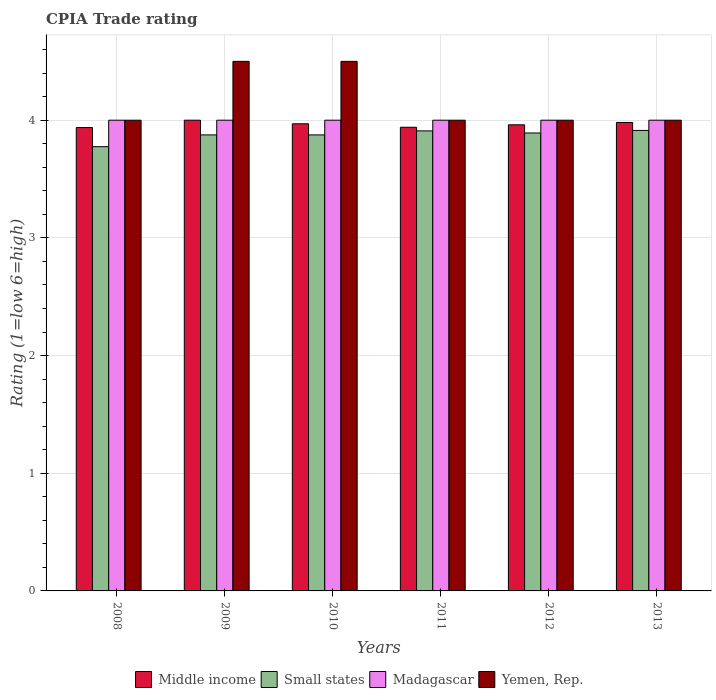How many groups of bars are there?
Provide a succinct answer. 6. How many bars are there on the 1st tick from the left?
Offer a very short reply. 4. How many bars are there on the 2nd tick from the right?
Provide a succinct answer. 4. What is the CPIA rating in Madagascar in 2010?
Your response must be concise. 4. Across all years, what is the maximum CPIA rating in Small states?
Provide a short and direct response. 3.91. Across all years, what is the minimum CPIA rating in Small states?
Make the answer very short. 3.77. What is the total CPIA rating in Middle income in the graph?
Offer a terse response. 23.79. What is the difference between the CPIA rating in Small states in 2009 and that in 2010?
Make the answer very short. 0. What is the difference between the CPIA rating in Yemen, Rep. in 2011 and the CPIA rating in Small states in 2013?
Your answer should be compact. 0.09. What is the average CPIA rating in Small states per year?
Give a very brief answer. 3.87. In the year 2012, what is the difference between the CPIA rating in Middle income and CPIA rating in Small states?
Give a very brief answer. 0.07. What is the ratio of the CPIA rating in Middle income in 2011 to that in 2012?
Your answer should be very brief. 0.99. Is the CPIA rating in Middle income in 2009 less than that in 2011?
Give a very brief answer. No. Is the difference between the CPIA rating in Middle income in 2011 and 2013 greater than the difference between the CPIA rating in Small states in 2011 and 2013?
Provide a succinct answer. No. What is the difference between the highest and the second highest CPIA rating in Yemen, Rep.?
Offer a terse response. 0. What is the difference between the highest and the lowest CPIA rating in Small states?
Ensure brevity in your answer.  0.14. In how many years, is the CPIA rating in Middle income greater than the average CPIA rating in Middle income taken over all years?
Your answer should be very brief. 3. What does the 2nd bar from the left in 2012 represents?
Keep it short and to the point. Small states. What does the 3rd bar from the right in 2010 represents?
Your response must be concise. Small states. Is it the case that in every year, the sum of the CPIA rating in Madagascar and CPIA rating in Yemen, Rep. is greater than the CPIA rating in Middle income?
Provide a short and direct response. Yes. Are all the bars in the graph horizontal?
Your answer should be very brief. No. What is the difference between two consecutive major ticks on the Y-axis?
Provide a short and direct response. 1. Are the values on the major ticks of Y-axis written in scientific E-notation?
Provide a succinct answer. No. Does the graph contain any zero values?
Give a very brief answer. No. Does the graph contain grids?
Make the answer very short. Yes. Where does the legend appear in the graph?
Offer a terse response. Bottom center. How many legend labels are there?
Provide a succinct answer. 4. How are the legend labels stacked?
Your response must be concise. Horizontal. What is the title of the graph?
Provide a short and direct response. CPIA Trade rating. What is the label or title of the X-axis?
Keep it short and to the point. Years. What is the label or title of the Y-axis?
Give a very brief answer. Rating (1=low 6=high). What is the Rating (1=low 6=high) of Middle income in 2008?
Make the answer very short. 3.94. What is the Rating (1=low 6=high) of Small states in 2008?
Offer a terse response. 3.77. What is the Rating (1=low 6=high) in Madagascar in 2008?
Give a very brief answer. 4. What is the Rating (1=low 6=high) of Yemen, Rep. in 2008?
Offer a terse response. 4. What is the Rating (1=low 6=high) of Small states in 2009?
Your answer should be compact. 3.88. What is the Rating (1=low 6=high) in Middle income in 2010?
Offer a terse response. 3.97. What is the Rating (1=low 6=high) of Small states in 2010?
Provide a succinct answer. 3.88. What is the Rating (1=low 6=high) of Madagascar in 2010?
Offer a terse response. 4. What is the Rating (1=low 6=high) of Yemen, Rep. in 2010?
Keep it short and to the point. 4.5. What is the Rating (1=low 6=high) in Middle income in 2011?
Your answer should be very brief. 3.94. What is the Rating (1=low 6=high) in Small states in 2011?
Ensure brevity in your answer.  3.91. What is the Rating (1=low 6=high) of Middle income in 2012?
Make the answer very short. 3.96. What is the Rating (1=low 6=high) of Small states in 2012?
Provide a short and direct response. 3.89. What is the Rating (1=low 6=high) of Yemen, Rep. in 2012?
Your answer should be compact. 4. What is the Rating (1=low 6=high) in Middle income in 2013?
Make the answer very short. 3.98. What is the Rating (1=low 6=high) of Small states in 2013?
Offer a very short reply. 3.91. What is the Rating (1=low 6=high) of Yemen, Rep. in 2013?
Offer a very short reply. 4. Across all years, what is the maximum Rating (1=low 6=high) of Middle income?
Offer a terse response. 4. Across all years, what is the maximum Rating (1=low 6=high) in Small states?
Provide a succinct answer. 3.91. Across all years, what is the minimum Rating (1=low 6=high) of Middle income?
Provide a short and direct response. 3.94. Across all years, what is the minimum Rating (1=low 6=high) of Small states?
Give a very brief answer. 3.77. What is the total Rating (1=low 6=high) in Middle income in the graph?
Your answer should be very brief. 23.79. What is the total Rating (1=low 6=high) of Small states in the graph?
Make the answer very short. 23.24. What is the total Rating (1=low 6=high) in Yemen, Rep. in the graph?
Give a very brief answer. 25. What is the difference between the Rating (1=low 6=high) in Middle income in 2008 and that in 2009?
Provide a succinct answer. -0.06. What is the difference between the Rating (1=low 6=high) of Madagascar in 2008 and that in 2009?
Provide a short and direct response. 0. What is the difference between the Rating (1=low 6=high) of Middle income in 2008 and that in 2010?
Your answer should be compact. -0.03. What is the difference between the Rating (1=low 6=high) of Small states in 2008 and that in 2010?
Your answer should be very brief. -0.1. What is the difference between the Rating (1=low 6=high) in Yemen, Rep. in 2008 and that in 2010?
Ensure brevity in your answer.  -0.5. What is the difference between the Rating (1=low 6=high) in Middle income in 2008 and that in 2011?
Offer a very short reply. -0. What is the difference between the Rating (1=low 6=high) of Small states in 2008 and that in 2011?
Your answer should be compact. -0.13. What is the difference between the Rating (1=low 6=high) in Yemen, Rep. in 2008 and that in 2011?
Ensure brevity in your answer.  0. What is the difference between the Rating (1=low 6=high) of Middle income in 2008 and that in 2012?
Provide a succinct answer. -0.02. What is the difference between the Rating (1=low 6=high) of Small states in 2008 and that in 2012?
Make the answer very short. -0.12. What is the difference between the Rating (1=low 6=high) of Madagascar in 2008 and that in 2012?
Your answer should be very brief. 0. What is the difference between the Rating (1=low 6=high) of Yemen, Rep. in 2008 and that in 2012?
Ensure brevity in your answer.  0. What is the difference between the Rating (1=low 6=high) in Middle income in 2008 and that in 2013?
Ensure brevity in your answer.  -0.04. What is the difference between the Rating (1=low 6=high) in Small states in 2008 and that in 2013?
Offer a terse response. -0.14. What is the difference between the Rating (1=low 6=high) of Middle income in 2009 and that in 2010?
Give a very brief answer. 0.03. What is the difference between the Rating (1=low 6=high) in Yemen, Rep. in 2009 and that in 2010?
Give a very brief answer. 0. What is the difference between the Rating (1=low 6=high) in Middle income in 2009 and that in 2011?
Your answer should be very brief. 0.06. What is the difference between the Rating (1=low 6=high) in Small states in 2009 and that in 2011?
Give a very brief answer. -0.03. What is the difference between the Rating (1=low 6=high) in Yemen, Rep. in 2009 and that in 2011?
Make the answer very short. 0.5. What is the difference between the Rating (1=low 6=high) of Middle income in 2009 and that in 2012?
Offer a very short reply. 0.04. What is the difference between the Rating (1=low 6=high) in Small states in 2009 and that in 2012?
Your response must be concise. -0.02. What is the difference between the Rating (1=low 6=high) of Madagascar in 2009 and that in 2012?
Keep it short and to the point. 0. What is the difference between the Rating (1=low 6=high) of Middle income in 2009 and that in 2013?
Keep it short and to the point. 0.02. What is the difference between the Rating (1=low 6=high) in Small states in 2009 and that in 2013?
Provide a succinct answer. -0.04. What is the difference between the Rating (1=low 6=high) in Madagascar in 2009 and that in 2013?
Your response must be concise. 0. What is the difference between the Rating (1=low 6=high) in Middle income in 2010 and that in 2011?
Your answer should be compact. 0.03. What is the difference between the Rating (1=low 6=high) in Small states in 2010 and that in 2011?
Provide a short and direct response. -0.03. What is the difference between the Rating (1=low 6=high) in Madagascar in 2010 and that in 2011?
Keep it short and to the point. 0. What is the difference between the Rating (1=low 6=high) of Middle income in 2010 and that in 2012?
Your response must be concise. 0.01. What is the difference between the Rating (1=low 6=high) of Small states in 2010 and that in 2012?
Ensure brevity in your answer.  -0.02. What is the difference between the Rating (1=low 6=high) of Middle income in 2010 and that in 2013?
Offer a very short reply. -0.01. What is the difference between the Rating (1=low 6=high) in Small states in 2010 and that in 2013?
Your answer should be very brief. -0.04. What is the difference between the Rating (1=low 6=high) of Yemen, Rep. in 2010 and that in 2013?
Make the answer very short. 0.5. What is the difference between the Rating (1=low 6=high) of Middle income in 2011 and that in 2012?
Offer a terse response. -0.02. What is the difference between the Rating (1=low 6=high) in Small states in 2011 and that in 2012?
Give a very brief answer. 0.02. What is the difference between the Rating (1=low 6=high) in Madagascar in 2011 and that in 2012?
Ensure brevity in your answer.  0. What is the difference between the Rating (1=low 6=high) of Yemen, Rep. in 2011 and that in 2012?
Make the answer very short. 0. What is the difference between the Rating (1=low 6=high) in Middle income in 2011 and that in 2013?
Offer a terse response. -0.04. What is the difference between the Rating (1=low 6=high) in Small states in 2011 and that in 2013?
Offer a terse response. -0. What is the difference between the Rating (1=low 6=high) in Yemen, Rep. in 2011 and that in 2013?
Provide a short and direct response. 0. What is the difference between the Rating (1=low 6=high) in Middle income in 2012 and that in 2013?
Keep it short and to the point. -0.02. What is the difference between the Rating (1=low 6=high) in Small states in 2012 and that in 2013?
Provide a succinct answer. -0.02. What is the difference between the Rating (1=low 6=high) of Middle income in 2008 and the Rating (1=low 6=high) of Small states in 2009?
Make the answer very short. 0.06. What is the difference between the Rating (1=low 6=high) in Middle income in 2008 and the Rating (1=low 6=high) in Madagascar in 2009?
Give a very brief answer. -0.06. What is the difference between the Rating (1=low 6=high) in Middle income in 2008 and the Rating (1=low 6=high) in Yemen, Rep. in 2009?
Keep it short and to the point. -0.56. What is the difference between the Rating (1=low 6=high) of Small states in 2008 and the Rating (1=low 6=high) of Madagascar in 2009?
Provide a short and direct response. -0.23. What is the difference between the Rating (1=low 6=high) of Small states in 2008 and the Rating (1=low 6=high) of Yemen, Rep. in 2009?
Make the answer very short. -0.72. What is the difference between the Rating (1=low 6=high) in Middle income in 2008 and the Rating (1=low 6=high) in Small states in 2010?
Your answer should be very brief. 0.06. What is the difference between the Rating (1=low 6=high) of Middle income in 2008 and the Rating (1=low 6=high) of Madagascar in 2010?
Provide a short and direct response. -0.06. What is the difference between the Rating (1=low 6=high) of Middle income in 2008 and the Rating (1=low 6=high) of Yemen, Rep. in 2010?
Provide a short and direct response. -0.56. What is the difference between the Rating (1=low 6=high) of Small states in 2008 and the Rating (1=low 6=high) of Madagascar in 2010?
Offer a very short reply. -0.23. What is the difference between the Rating (1=low 6=high) of Small states in 2008 and the Rating (1=low 6=high) of Yemen, Rep. in 2010?
Your answer should be very brief. -0.72. What is the difference between the Rating (1=low 6=high) in Madagascar in 2008 and the Rating (1=low 6=high) in Yemen, Rep. in 2010?
Offer a terse response. -0.5. What is the difference between the Rating (1=low 6=high) in Middle income in 2008 and the Rating (1=low 6=high) in Small states in 2011?
Keep it short and to the point. 0.03. What is the difference between the Rating (1=low 6=high) of Middle income in 2008 and the Rating (1=low 6=high) of Madagascar in 2011?
Provide a short and direct response. -0.06. What is the difference between the Rating (1=low 6=high) in Middle income in 2008 and the Rating (1=low 6=high) in Yemen, Rep. in 2011?
Keep it short and to the point. -0.06. What is the difference between the Rating (1=low 6=high) in Small states in 2008 and the Rating (1=low 6=high) in Madagascar in 2011?
Ensure brevity in your answer.  -0.23. What is the difference between the Rating (1=low 6=high) in Small states in 2008 and the Rating (1=low 6=high) in Yemen, Rep. in 2011?
Your answer should be compact. -0.23. What is the difference between the Rating (1=low 6=high) in Middle income in 2008 and the Rating (1=low 6=high) in Small states in 2012?
Your response must be concise. 0.05. What is the difference between the Rating (1=low 6=high) in Middle income in 2008 and the Rating (1=low 6=high) in Madagascar in 2012?
Make the answer very short. -0.06. What is the difference between the Rating (1=low 6=high) in Middle income in 2008 and the Rating (1=low 6=high) in Yemen, Rep. in 2012?
Your response must be concise. -0.06. What is the difference between the Rating (1=low 6=high) in Small states in 2008 and the Rating (1=low 6=high) in Madagascar in 2012?
Provide a succinct answer. -0.23. What is the difference between the Rating (1=low 6=high) in Small states in 2008 and the Rating (1=low 6=high) in Yemen, Rep. in 2012?
Your response must be concise. -0.23. What is the difference between the Rating (1=low 6=high) of Middle income in 2008 and the Rating (1=low 6=high) of Small states in 2013?
Make the answer very short. 0.02. What is the difference between the Rating (1=low 6=high) in Middle income in 2008 and the Rating (1=low 6=high) in Madagascar in 2013?
Offer a terse response. -0.06. What is the difference between the Rating (1=low 6=high) of Middle income in 2008 and the Rating (1=low 6=high) of Yemen, Rep. in 2013?
Ensure brevity in your answer.  -0.06. What is the difference between the Rating (1=low 6=high) of Small states in 2008 and the Rating (1=low 6=high) of Madagascar in 2013?
Ensure brevity in your answer.  -0.23. What is the difference between the Rating (1=low 6=high) of Small states in 2008 and the Rating (1=low 6=high) of Yemen, Rep. in 2013?
Your answer should be compact. -0.23. What is the difference between the Rating (1=low 6=high) of Small states in 2009 and the Rating (1=low 6=high) of Madagascar in 2010?
Provide a succinct answer. -0.12. What is the difference between the Rating (1=low 6=high) in Small states in 2009 and the Rating (1=low 6=high) in Yemen, Rep. in 2010?
Offer a terse response. -0.62. What is the difference between the Rating (1=low 6=high) of Madagascar in 2009 and the Rating (1=low 6=high) of Yemen, Rep. in 2010?
Provide a short and direct response. -0.5. What is the difference between the Rating (1=low 6=high) in Middle income in 2009 and the Rating (1=low 6=high) in Small states in 2011?
Your answer should be very brief. 0.09. What is the difference between the Rating (1=low 6=high) in Middle income in 2009 and the Rating (1=low 6=high) in Yemen, Rep. in 2011?
Your answer should be compact. 0. What is the difference between the Rating (1=low 6=high) in Small states in 2009 and the Rating (1=low 6=high) in Madagascar in 2011?
Your response must be concise. -0.12. What is the difference between the Rating (1=low 6=high) of Small states in 2009 and the Rating (1=low 6=high) of Yemen, Rep. in 2011?
Your response must be concise. -0.12. What is the difference between the Rating (1=low 6=high) in Middle income in 2009 and the Rating (1=low 6=high) in Small states in 2012?
Provide a succinct answer. 0.11. What is the difference between the Rating (1=low 6=high) of Small states in 2009 and the Rating (1=low 6=high) of Madagascar in 2012?
Your answer should be very brief. -0.12. What is the difference between the Rating (1=low 6=high) in Small states in 2009 and the Rating (1=low 6=high) in Yemen, Rep. in 2012?
Offer a very short reply. -0.12. What is the difference between the Rating (1=low 6=high) in Middle income in 2009 and the Rating (1=low 6=high) in Small states in 2013?
Ensure brevity in your answer.  0.09. What is the difference between the Rating (1=low 6=high) of Middle income in 2009 and the Rating (1=low 6=high) of Madagascar in 2013?
Your answer should be compact. 0. What is the difference between the Rating (1=low 6=high) of Middle income in 2009 and the Rating (1=low 6=high) of Yemen, Rep. in 2013?
Your answer should be very brief. 0. What is the difference between the Rating (1=low 6=high) of Small states in 2009 and the Rating (1=low 6=high) of Madagascar in 2013?
Provide a short and direct response. -0.12. What is the difference between the Rating (1=low 6=high) in Small states in 2009 and the Rating (1=low 6=high) in Yemen, Rep. in 2013?
Provide a short and direct response. -0.12. What is the difference between the Rating (1=low 6=high) in Middle income in 2010 and the Rating (1=low 6=high) in Small states in 2011?
Make the answer very short. 0.06. What is the difference between the Rating (1=low 6=high) in Middle income in 2010 and the Rating (1=low 6=high) in Madagascar in 2011?
Your answer should be compact. -0.03. What is the difference between the Rating (1=low 6=high) of Middle income in 2010 and the Rating (1=low 6=high) of Yemen, Rep. in 2011?
Keep it short and to the point. -0.03. What is the difference between the Rating (1=low 6=high) of Small states in 2010 and the Rating (1=low 6=high) of Madagascar in 2011?
Offer a very short reply. -0.12. What is the difference between the Rating (1=low 6=high) of Small states in 2010 and the Rating (1=low 6=high) of Yemen, Rep. in 2011?
Provide a short and direct response. -0.12. What is the difference between the Rating (1=low 6=high) of Madagascar in 2010 and the Rating (1=low 6=high) of Yemen, Rep. in 2011?
Your answer should be very brief. 0. What is the difference between the Rating (1=low 6=high) in Middle income in 2010 and the Rating (1=low 6=high) in Small states in 2012?
Your answer should be very brief. 0.08. What is the difference between the Rating (1=low 6=high) in Middle income in 2010 and the Rating (1=low 6=high) in Madagascar in 2012?
Provide a succinct answer. -0.03. What is the difference between the Rating (1=low 6=high) of Middle income in 2010 and the Rating (1=low 6=high) of Yemen, Rep. in 2012?
Your response must be concise. -0.03. What is the difference between the Rating (1=low 6=high) in Small states in 2010 and the Rating (1=low 6=high) in Madagascar in 2012?
Keep it short and to the point. -0.12. What is the difference between the Rating (1=low 6=high) of Small states in 2010 and the Rating (1=low 6=high) of Yemen, Rep. in 2012?
Your answer should be very brief. -0.12. What is the difference between the Rating (1=low 6=high) of Madagascar in 2010 and the Rating (1=low 6=high) of Yemen, Rep. in 2012?
Provide a succinct answer. 0. What is the difference between the Rating (1=low 6=high) in Middle income in 2010 and the Rating (1=low 6=high) in Small states in 2013?
Your answer should be compact. 0.06. What is the difference between the Rating (1=low 6=high) of Middle income in 2010 and the Rating (1=low 6=high) of Madagascar in 2013?
Provide a short and direct response. -0.03. What is the difference between the Rating (1=low 6=high) of Middle income in 2010 and the Rating (1=low 6=high) of Yemen, Rep. in 2013?
Give a very brief answer. -0.03. What is the difference between the Rating (1=low 6=high) in Small states in 2010 and the Rating (1=low 6=high) in Madagascar in 2013?
Your answer should be very brief. -0.12. What is the difference between the Rating (1=low 6=high) of Small states in 2010 and the Rating (1=low 6=high) of Yemen, Rep. in 2013?
Offer a terse response. -0.12. What is the difference between the Rating (1=low 6=high) in Middle income in 2011 and the Rating (1=low 6=high) in Small states in 2012?
Offer a very short reply. 0.05. What is the difference between the Rating (1=low 6=high) of Middle income in 2011 and the Rating (1=low 6=high) of Madagascar in 2012?
Give a very brief answer. -0.06. What is the difference between the Rating (1=low 6=high) of Middle income in 2011 and the Rating (1=low 6=high) of Yemen, Rep. in 2012?
Offer a terse response. -0.06. What is the difference between the Rating (1=low 6=high) in Small states in 2011 and the Rating (1=low 6=high) in Madagascar in 2012?
Your answer should be compact. -0.09. What is the difference between the Rating (1=low 6=high) in Small states in 2011 and the Rating (1=low 6=high) in Yemen, Rep. in 2012?
Provide a short and direct response. -0.09. What is the difference between the Rating (1=low 6=high) in Madagascar in 2011 and the Rating (1=low 6=high) in Yemen, Rep. in 2012?
Your answer should be compact. 0. What is the difference between the Rating (1=low 6=high) of Middle income in 2011 and the Rating (1=low 6=high) of Small states in 2013?
Offer a very short reply. 0.03. What is the difference between the Rating (1=low 6=high) in Middle income in 2011 and the Rating (1=low 6=high) in Madagascar in 2013?
Your response must be concise. -0.06. What is the difference between the Rating (1=low 6=high) of Middle income in 2011 and the Rating (1=low 6=high) of Yemen, Rep. in 2013?
Provide a succinct answer. -0.06. What is the difference between the Rating (1=low 6=high) in Small states in 2011 and the Rating (1=low 6=high) in Madagascar in 2013?
Your answer should be very brief. -0.09. What is the difference between the Rating (1=low 6=high) of Small states in 2011 and the Rating (1=low 6=high) of Yemen, Rep. in 2013?
Offer a terse response. -0.09. What is the difference between the Rating (1=low 6=high) in Middle income in 2012 and the Rating (1=low 6=high) in Small states in 2013?
Your answer should be very brief. 0.05. What is the difference between the Rating (1=low 6=high) of Middle income in 2012 and the Rating (1=low 6=high) of Madagascar in 2013?
Provide a short and direct response. -0.04. What is the difference between the Rating (1=low 6=high) in Middle income in 2012 and the Rating (1=low 6=high) in Yemen, Rep. in 2013?
Provide a short and direct response. -0.04. What is the difference between the Rating (1=low 6=high) of Small states in 2012 and the Rating (1=low 6=high) of Madagascar in 2013?
Offer a terse response. -0.11. What is the difference between the Rating (1=low 6=high) of Small states in 2012 and the Rating (1=low 6=high) of Yemen, Rep. in 2013?
Offer a very short reply. -0.11. What is the difference between the Rating (1=low 6=high) in Madagascar in 2012 and the Rating (1=low 6=high) in Yemen, Rep. in 2013?
Provide a short and direct response. 0. What is the average Rating (1=low 6=high) of Middle income per year?
Provide a short and direct response. 3.96. What is the average Rating (1=low 6=high) in Small states per year?
Make the answer very short. 3.87. What is the average Rating (1=low 6=high) of Madagascar per year?
Keep it short and to the point. 4. What is the average Rating (1=low 6=high) of Yemen, Rep. per year?
Provide a succinct answer. 4.17. In the year 2008, what is the difference between the Rating (1=low 6=high) of Middle income and Rating (1=low 6=high) of Small states?
Give a very brief answer. 0.16. In the year 2008, what is the difference between the Rating (1=low 6=high) in Middle income and Rating (1=low 6=high) in Madagascar?
Your answer should be compact. -0.06. In the year 2008, what is the difference between the Rating (1=low 6=high) of Middle income and Rating (1=low 6=high) of Yemen, Rep.?
Your response must be concise. -0.06. In the year 2008, what is the difference between the Rating (1=low 6=high) of Small states and Rating (1=low 6=high) of Madagascar?
Your answer should be compact. -0.23. In the year 2008, what is the difference between the Rating (1=low 6=high) of Small states and Rating (1=low 6=high) of Yemen, Rep.?
Offer a terse response. -0.23. In the year 2008, what is the difference between the Rating (1=low 6=high) in Madagascar and Rating (1=low 6=high) in Yemen, Rep.?
Offer a terse response. 0. In the year 2009, what is the difference between the Rating (1=low 6=high) in Middle income and Rating (1=low 6=high) in Madagascar?
Your answer should be very brief. 0. In the year 2009, what is the difference between the Rating (1=low 6=high) in Small states and Rating (1=low 6=high) in Madagascar?
Give a very brief answer. -0.12. In the year 2009, what is the difference between the Rating (1=low 6=high) of Small states and Rating (1=low 6=high) of Yemen, Rep.?
Your answer should be very brief. -0.62. In the year 2009, what is the difference between the Rating (1=low 6=high) in Madagascar and Rating (1=low 6=high) in Yemen, Rep.?
Your response must be concise. -0.5. In the year 2010, what is the difference between the Rating (1=low 6=high) in Middle income and Rating (1=low 6=high) in Small states?
Give a very brief answer. 0.09. In the year 2010, what is the difference between the Rating (1=low 6=high) in Middle income and Rating (1=low 6=high) in Madagascar?
Offer a terse response. -0.03. In the year 2010, what is the difference between the Rating (1=low 6=high) of Middle income and Rating (1=low 6=high) of Yemen, Rep.?
Provide a succinct answer. -0.53. In the year 2010, what is the difference between the Rating (1=low 6=high) in Small states and Rating (1=low 6=high) in Madagascar?
Offer a terse response. -0.12. In the year 2010, what is the difference between the Rating (1=low 6=high) of Small states and Rating (1=low 6=high) of Yemen, Rep.?
Make the answer very short. -0.62. In the year 2010, what is the difference between the Rating (1=low 6=high) of Madagascar and Rating (1=low 6=high) of Yemen, Rep.?
Your response must be concise. -0.5. In the year 2011, what is the difference between the Rating (1=low 6=high) in Middle income and Rating (1=low 6=high) in Small states?
Provide a succinct answer. 0.03. In the year 2011, what is the difference between the Rating (1=low 6=high) of Middle income and Rating (1=low 6=high) of Madagascar?
Your response must be concise. -0.06. In the year 2011, what is the difference between the Rating (1=low 6=high) of Middle income and Rating (1=low 6=high) of Yemen, Rep.?
Give a very brief answer. -0.06. In the year 2011, what is the difference between the Rating (1=low 6=high) in Small states and Rating (1=low 6=high) in Madagascar?
Keep it short and to the point. -0.09. In the year 2011, what is the difference between the Rating (1=low 6=high) of Small states and Rating (1=low 6=high) of Yemen, Rep.?
Make the answer very short. -0.09. In the year 2011, what is the difference between the Rating (1=low 6=high) of Madagascar and Rating (1=low 6=high) of Yemen, Rep.?
Ensure brevity in your answer.  0. In the year 2012, what is the difference between the Rating (1=low 6=high) in Middle income and Rating (1=low 6=high) in Small states?
Give a very brief answer. 0.07. In the year 2012, what is the difference between the Rating (1=low 6=high) in Middle income and Rating (1=low 6=high) in Madagascar?
Offer a terse response. -0.04. In the year 2012, what is the difference between the Rating (1=low 6=high) of Middle income and Rating (1=low 6=high) of Yemen, Rep.?
Your answer should be compact. -0.04. In the year 2012, what is the difference between the Rating (1=low 6=high) of Small states and Rating (1=low 6=high) of Madagascar?
Your answer should be very brief. -0.11. In the year 2012, what is the difference between the Rating (1=low 6=high) in Small states and Rating (1=low 6=high) in Yemen, Rep.?
Provide a short and direct response. -0.11. In the year 2012, what is the difference between the Rating (1=low 6=high) of Madagascar and Rating (1=low 6=high) of Yemen, Rep.?
Your answer should be very brief. 0. In the year 2013, what is the difference between the Rating (1=low 6=high) of Middle income and Rating (1=low 6=high) of Small states?
Provide a short and direct response. 0.07. In the year 2013, what is the difference between the Rating (1=low 6=high) in Middle income and Rating (1=low 6=high) in Madagascar?
Your answer should be compact. -0.02. In the year 2013, what is the difference between the Rating (1=low 6=high) in Middle income and Rating (1=low 6=high) in Yemen, Rep.?
Provide a succinct answer. -0.02. In the year 2013, what is the difference between the Rating (1=low 6=high) in Small states and Rating (1=low 6=high) in Madagascar?
Your answer should be very brief. -0.09. In the year 2013, what is the difference between the Rating (1=low 6=high) in Small states and Rating (1=low 6=high) in Yemen, Rep.?
Keep it short and to the point. -0.09. What is the ratio of the Rating (1=low 6=high) of Middle income in 2008 to that in 2009?
Your answer should be very brief. 0.98. What is the ratio of the Rating (1=low 6=high) in Small states in 2008 to that in 2009?
Your answer should be very brief. 0.97. What is the ratio of the Rating (1=low 6=high) in Madagascar in 2008 to that in 2009?
Ensure brevity in your answer.  1. What is the ratio of the Rating (1=low 6=high) in Small states in 2008 to that in 2010?
Make the answer very short. 0.97. What is the ratio of the Rating (1=low 6=high) in Middle income in 2008 to that in 2011?
Offer a very short reply. 1. What is the ratio of the Rating (1=low 6=high) in Small states in 2008 to that in 2011?
Your response must be concise. 0.97. What is the ratio of the Rating (1=low 6=high) of Middle income in 2008 to that in 2012?
Offer a terse response. 0.99. What is the ratio of the Rating (1=low 6=high) in Small states in 2008 to that in 2012?
Offer a very short reply. 0.97. What is the ratio of the Rating (1=low 6=high) of Madagascar in 2008 to that in 2012?
Your answer should be very brief. 1. What is the ratio of the Rating (1=low 6=high) in Yemen, Rep. in 2008 to that in 2012?
Provide a short and direct response. 1. What is the ratio of the Rating (1=low 6=high) in Middle income in 2008 to that in 2013?
Offer a terse response. 0.99. What is the ratio of the Rating (1=low 6=high) of Small states in 2008 to that in 2013?
Give a very brief answer. 0.96. What is the ratio of the Rating (1=low 6=high) of Yemen, Rep. in 2008 to that in 2013?
Give a very brief answer. 1. What is the ratio of the Rating (1=low 6=high) in Middle income in 2009 to that in 2010?
Provide a succinct answer. 1.01. What is the ratio of the Rating (1=low 6=high) of Madagascar in 2009 to that in 2010?
Give a very brief answer. 1. What is the ratio of the Rating (1=low 6=high) of Middle income in 2009 to that in 2011?
Your response must be concise. 1.02. What is the ratio of the Rating (1=low 6=high) of Small states in 2009 to that in 2011?
Offer a very short reply. 0.99. What is the ratio of the Rating (1=low 6=high) in Yemen, Rep. in 2009 to that in 2011?
Give a very brief answer. 1.12. What is the ratio of the Rating (1=low 6=high) in Middle income in 2009 to that in 2012?
Provide a succinct answer. 1.01. What is the ratio of the Rating (1=low 6=high) in Yemen, Rep. in 2009 to that in 2012?
Your answer should be compact. 1.12. What is the ratio of the Rating (1=low 6=high) of Middle income in 2009 to that in 2013?
Offer a very short reply. 1. What is the ratio of the Rating (1=low 6=high) in Small states in 2009 to that in 2013?
Give a very brief answer. 0.99. What is the ratio of the Rating (1=low 6=high) of Madagascar in 2009 to that in 2013?
Provide a short and direct response. 1. What is the ratio of the Rating (1=low 6=high) of Middle income in 2010 to that in 2011?
Provide a succinct answer. 1.01. What is the ratio of the Rating (1=low 6=high) of Small states in 2010 to that in 2011?
Your answer should be very brief. 0.99. What is the ratio of the Rating (1=low 6=high) of Madagascar in 2010 to that in 2011?
Provide a succinct answer. 1. What is the ratio of the Rating (1=low 6=high) in Middle income in 2010 to that in 2012?
Provide a succinct answer. 1. What is the ratio of the Rating (1=low 6=high) of Yemen, Rep. in 2010 to that in 2012?
Make the answer very short. 1.12. What is the ratio of the Rating (1=low 6=high) of Small states in 2010 to that in 2013?
Make the answer very short. 0.99. What is the ratio of the Rating (1=low 6=high) in Small states in 2011 to that in 2012?
Your answer should be very brief. 1. What is the ratio of the Rating (1=low 6=high) in Madagascar in 2011 to that in 2012?
Your response must be concise. 1. What is the ratio of the Rating (1=low 6=high) of Small states in 2011 to that in 2013?
Make the answer very short. 1. What is the ratio of the Rating (1=low 6=high) in Middle income in 2012 to that in 2013?
Offer a very short reply. 0.99. What is the ratio of the Rating (1=low 6=high) of Madagascar in 2012 to that in 2013?
Make the answer very short. 1. What is the ratio of the Rating (1=low 6=high) in Yemen, Rep. in 2012 to that in 2013?
Make the answer very short. 1. What is the difference between the highest and the second highest Rating (1=low 6=high) of Middle income?
Make the answer very short. 0.02. What is the difference between the highest and the second highest Rating (1=low 6=high) in Small states?
Make the answer very short. 0. What is the difference between the highest and the second highest Rating (1=low 6=high) of Madagascar?
Keep it short and to the point. 0. What is the difference between the highest and the second highest Rating (1=low 6=high) in Yemen, Rep.?
Offer a very short reply. 0. What is the difference between the highest and the lowest Rating (1=low 6=high) in Middle income?
Provide a succinct answer. 0.06. What is the difference between the highest and the lowest Rating (1=low 6=high) in Small states?
Your answer should be very brief. 0.14. What is the difference between the highest and the lowest Rating (1=low 6=high) of Madagascar?
Keep it short and to the point. 0. 